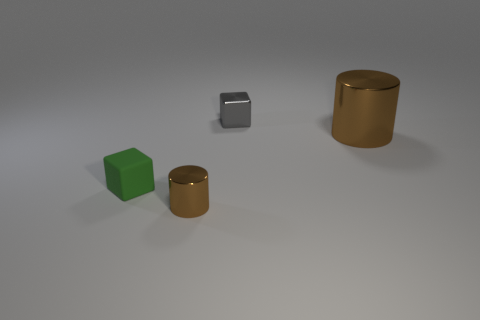Subtract all blue cylinders. Subtract all gray balls. How many cylinders are left? 2 Add 2 metallic cubes. How many objects exist? 6 Add 3 gray shiny objects. How many gray shiny objects are left? 4 Add 1 tiny brown cylinders. How many tiny brown cylinders exist? 2 Subtract 0 cyan balls. How many objects are left? 4 Subtract all green matte cubes. Subtract all tiny shiny things. How many objects are left? 1 